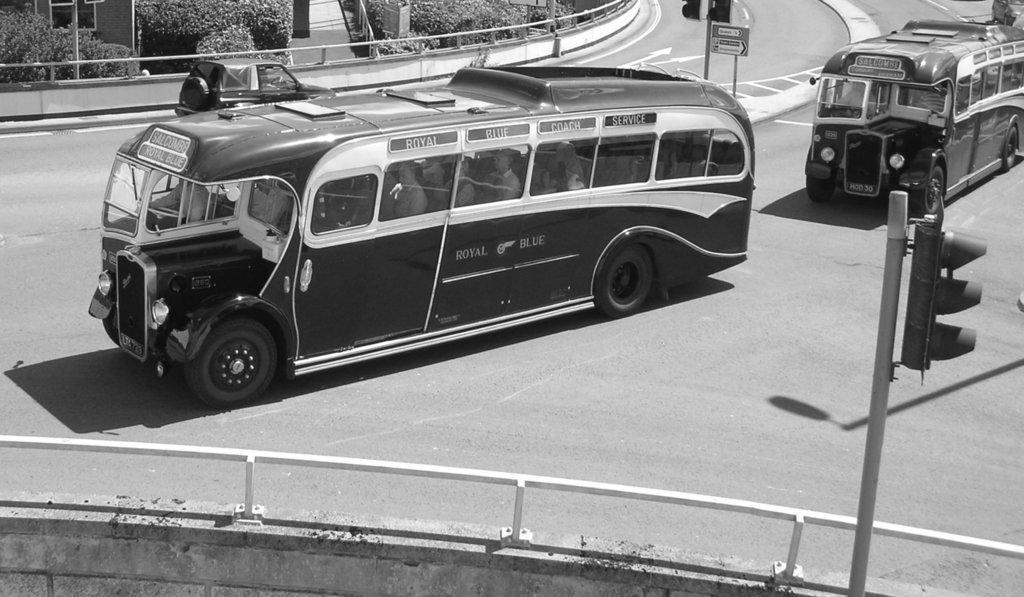Describe this image in one or two sentences. In this image we can see vehicles on the road and there are traffic poles. In the center there is a sign board. In the background there are bushes and a railing. At the bottom there is a wall. 